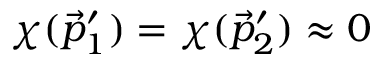Convert formula to latex. <formula><loc_0><loc_0><loc_500><loc_500>\chi ( \vec { p } _ { 1 } ^ { \prime } ) = \chi ( \vec { p } _ { 2 } ^ { \prime } ) \approx 0</formula> 